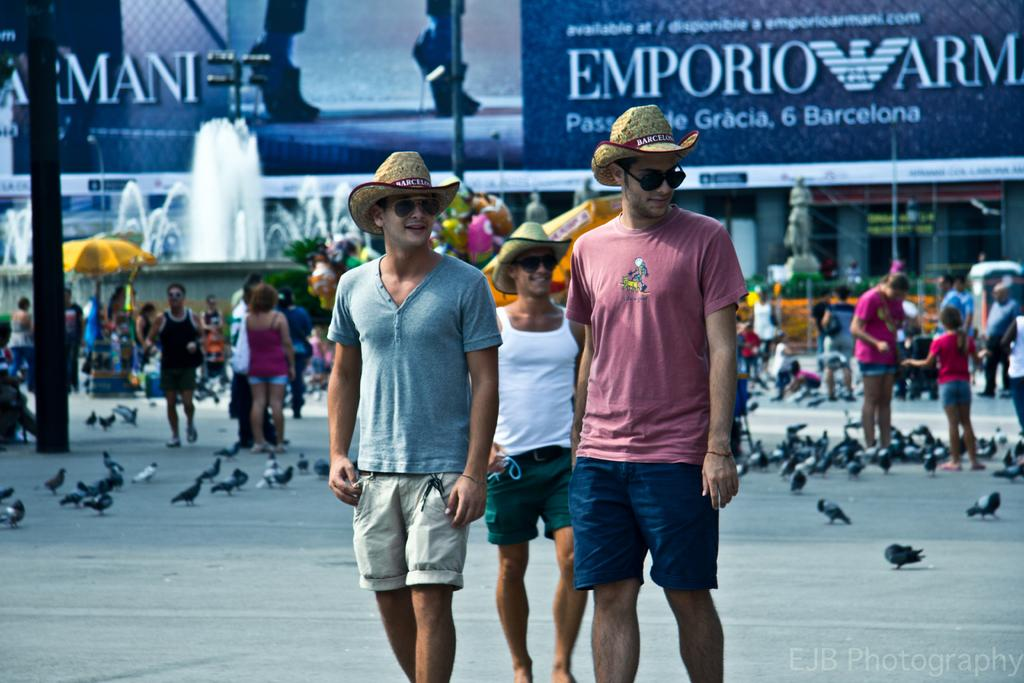What is happening on the road in the image? There are people on the road in the image. What type of animals can be seen in the image? Birds are visible in the image. What can be seen in the background of the image? There is a water fountain, a sculpture, and buildings in the background of the image. What is on the buildings in the background? There are boards visible on the buildings. Can you see a crib on the ship in the image? There is no ship or crib present in the image. What type of spring is visible in the image? There is no spring present in the image. 